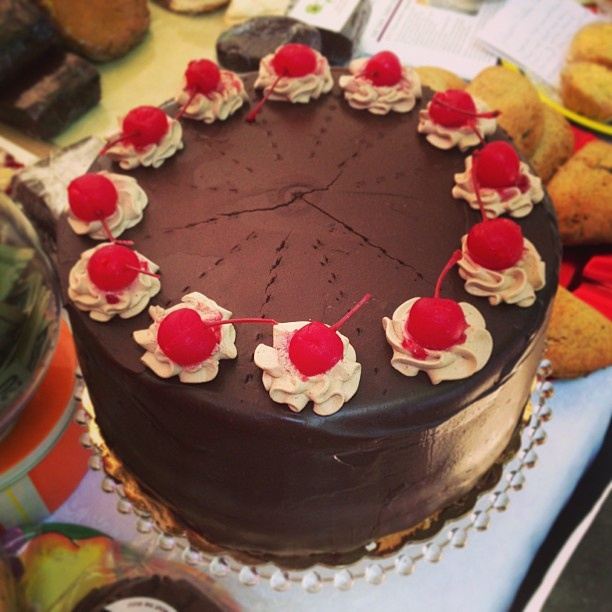Describe the objects in this image and their specific colors. I can see a cake in maroon, black, and brown tones in this image. 